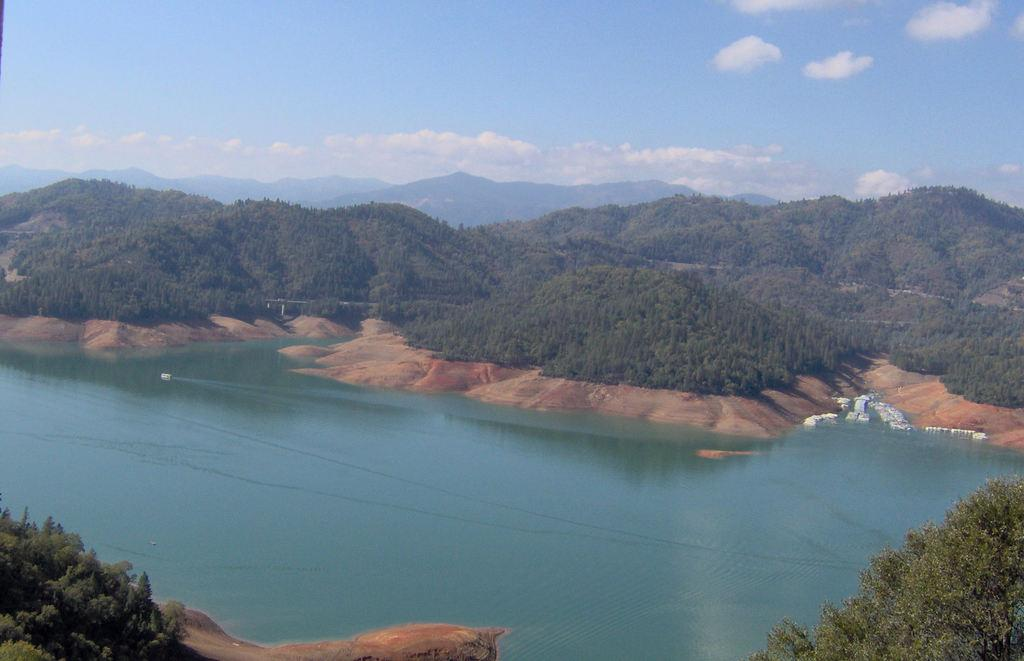What is the main feature of the image? There is a river flowing in the image. What can be seen in the background of the image? There are trees and hills in the background of the image. What is visible above the landscape in the image? The sky is visible in the image. What can be observed in the sky? There are clouds in the sky. What type of flesh can be seen hanging from the trees in the image? There is no flesh present in the image; it features a river, trees, hills, and clouds. 